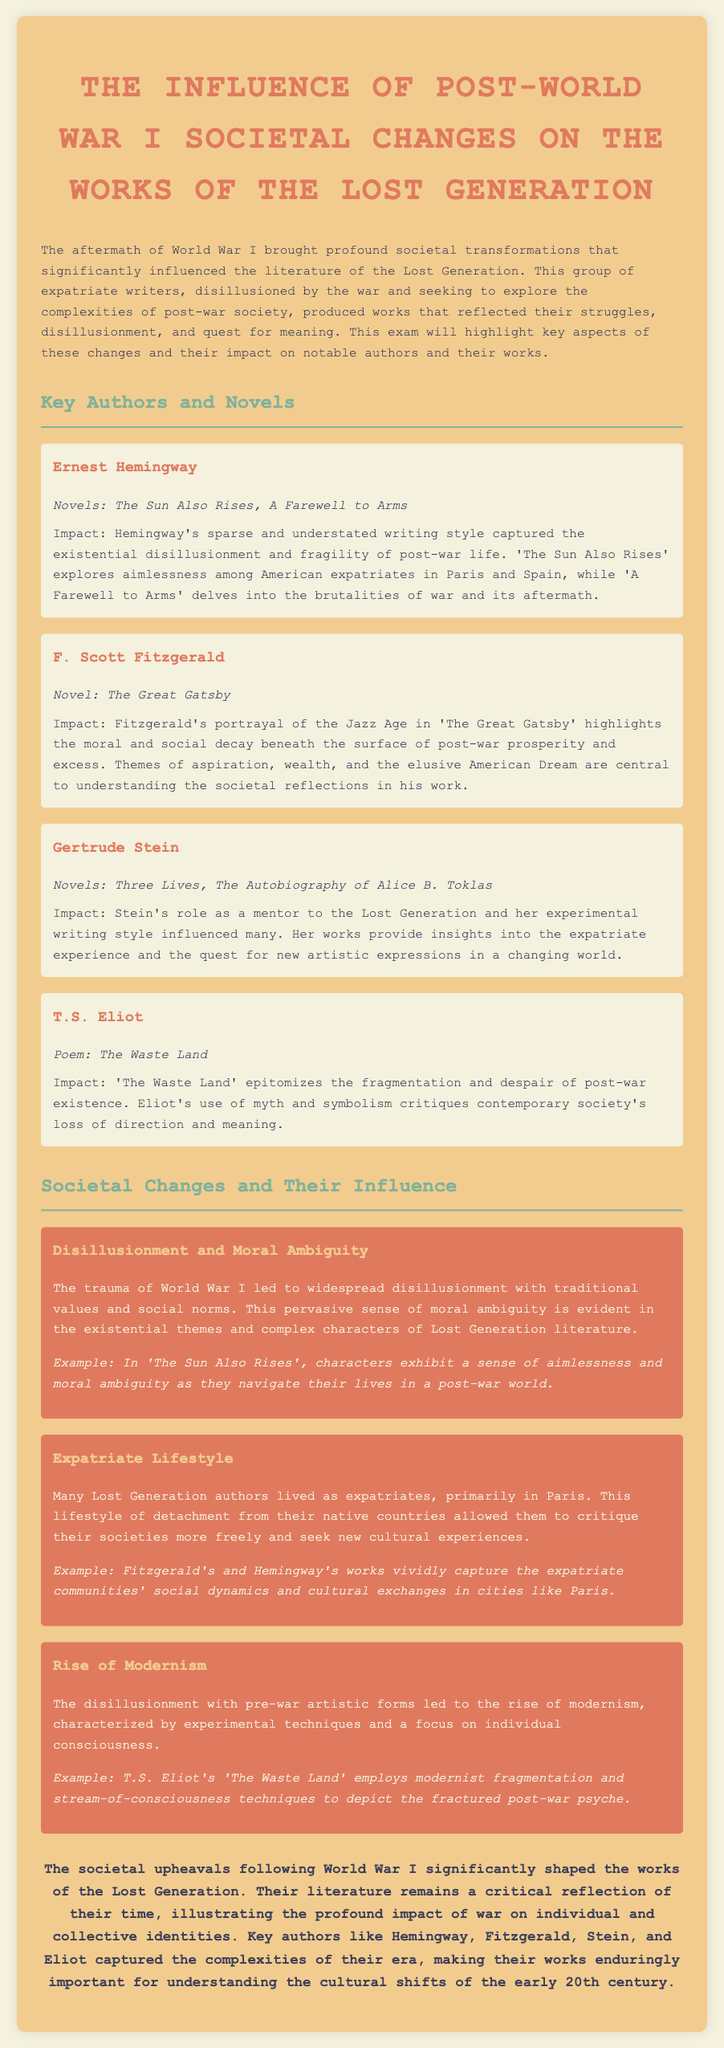What are the two novels by Ernest Hemingway? The document lists 'The Sun Also Rises' and 'A Farewell to Arms' as the novels by Ernest Hemingway.
Answer: The Sun Also Rises, A Farewell to Arms Which author wrote 'The Great Gatsby'? The document states that F. Scott Fitzgerald is the author of 'The Great Gatsby'.
Answer: F. Scott Fitzgerald What is a key theme in 'The Great Gatsby'? The document highlights aspiration, wealth, and the elusive American Dream as central themes in 'The Great Gatsby'.
Answer: Aspiration, wealth, the elusive American Dream What poem is T.S. Eliot known for that reflects post-war despair? The document indicates that 'The Waste Land' is the poem by T.S. Eliot reflecting post-war despair.
Answer: The Waste Land What societal change is discussed in relation to the disillusionment following World War I? The document connects the trauma of World War I to widespread disillusionment with traditional values and social norms.
Answer: Disillusionment with traditional values How did the expatriate lifestyle influence Lost Generation authors? The document notes that living as expatriates allowed them to critique their societies more freely.
Answer: Allowed critique of their societies more freely What literary movement emerged as a result of disillusionment with pre-war artistic forms? The document mentions the rise of modernism characterized by experimental techniques.
Answer: Modernism What writing technique does T.S. Eliot use in 'The Waste Land'? The document states that Eliot employs modernist fragmentation and stream-of-consciousness techniques in 'The Waste Land'.
Answer: Modernist fragmentation and stream-of-consciousness techniques 